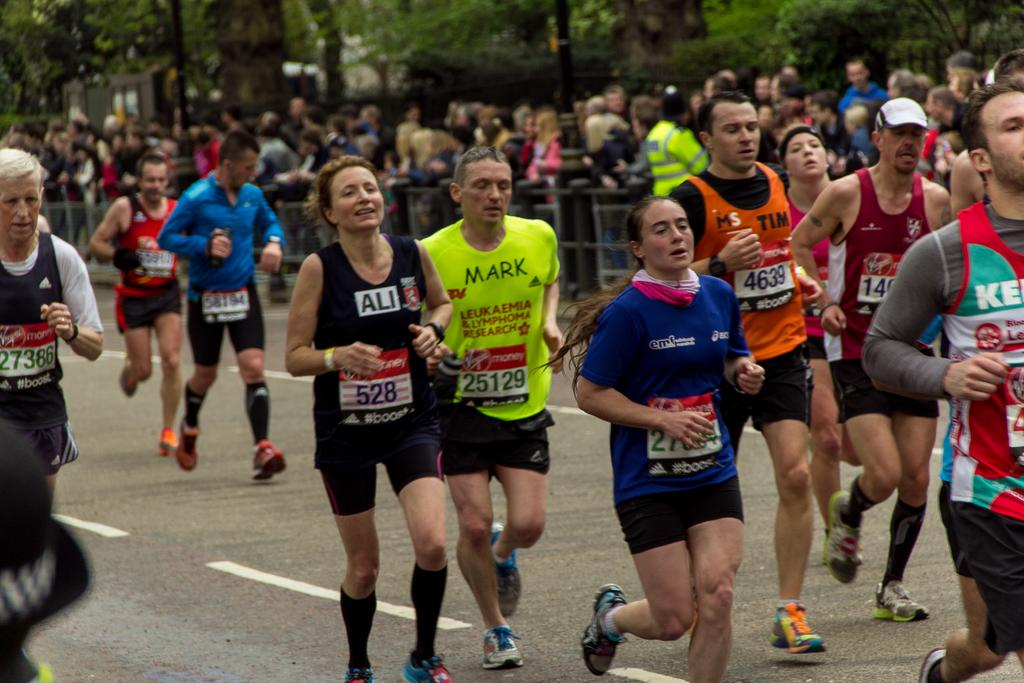What are the people in the image doing? The people in the image are running. What is separating the people running from the people standing? There is a barrier in the image. How many people are standing behind the barrier? There are many people standing behind the barrier. What type of vegetation can be seen in the image? Trees are visible in the image. What type of pathway is present in the image? There is a road in the image. What type of ball is being used by the men in the image? There are no men or balls present in the image; it features people running and a barrier. 